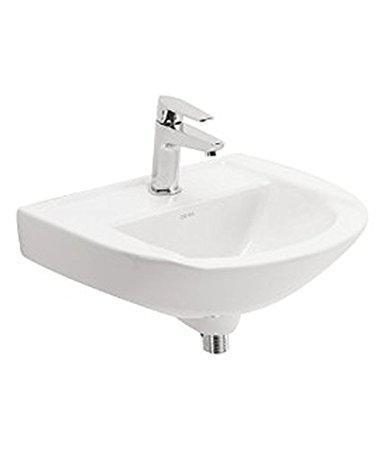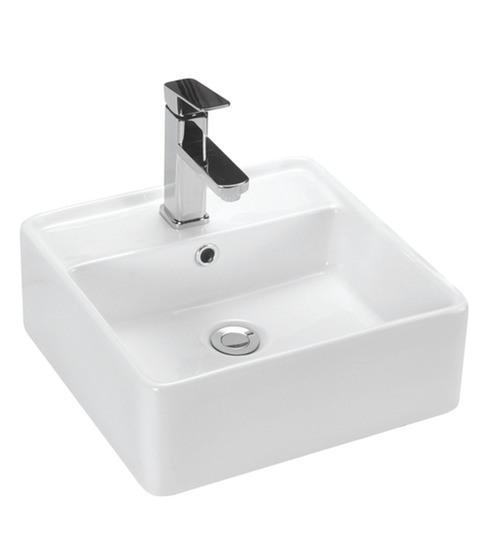The first image is the image on the left, the second image is the image on the right. Assess this claim about the two images: "There is a square sink in one of the images.". Correct or not? Answer yes or no. Yes. 